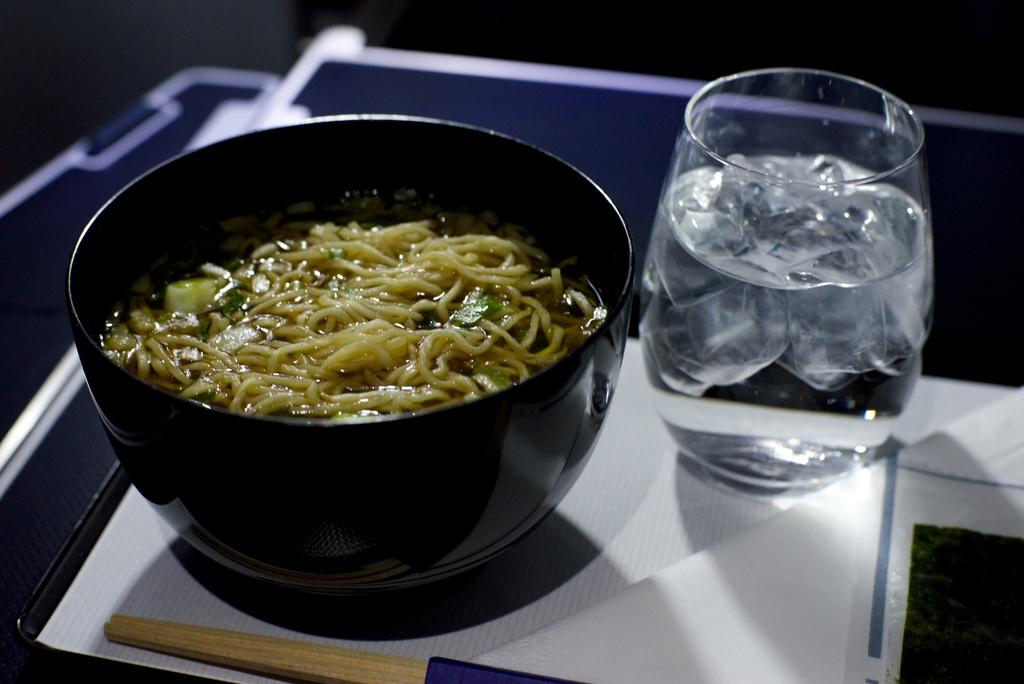What is in the bowl that is visible in the image? There is a bowl with food in the image. What is in the glass that is visible in the image? There is a glass with water in the image. What object can be seen in the image that is not related to food or drink? There is a stick in the image. What type of dirt can be seen in the image? There is no dirt present in the image. How many people are in the crowd in the image? There is no crowd present in the image. 